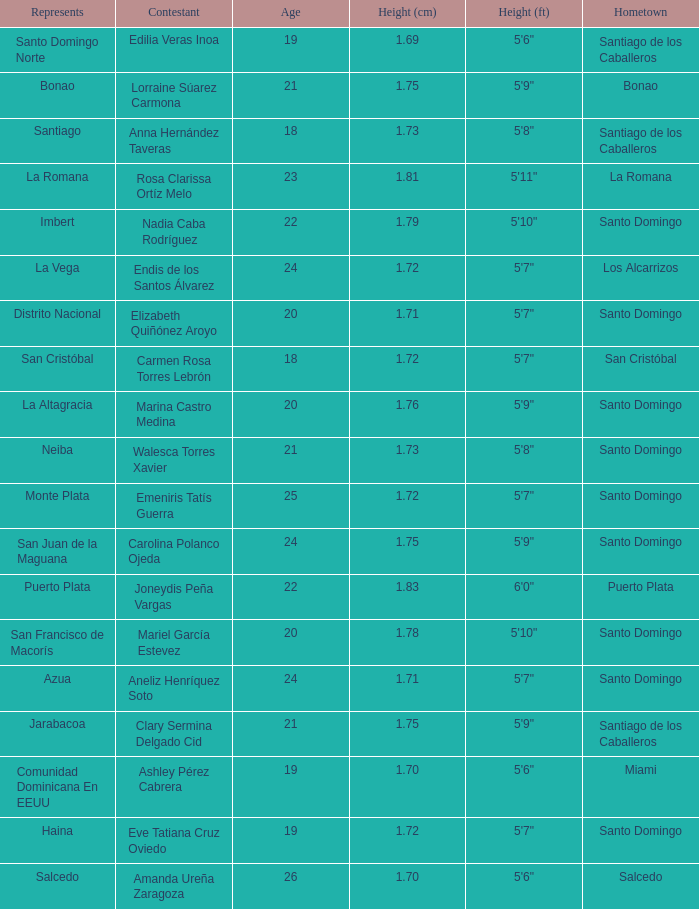Name the represents for 1.76 cm La Altagracia. 